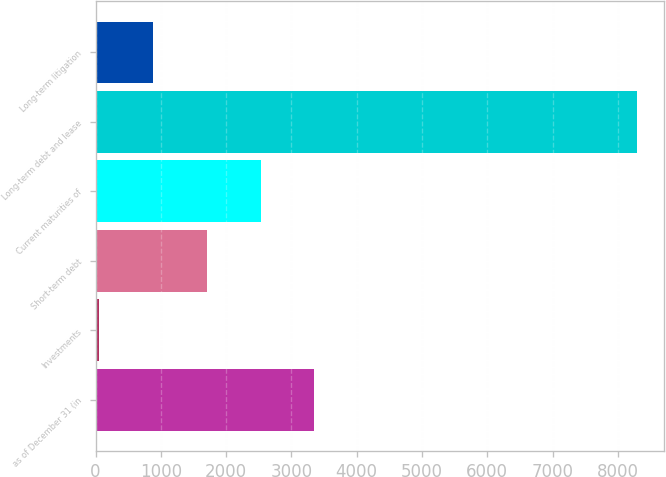Convert chart. <chart><loc_0><loc_0><loc_500><loc_500><bar_chart><fcel>as of December 31 (in<fcel>Investments<fcel>Short-term debt<fcel>Current maturities of<fcel>Long-term debt and lease<fcel>Long-term litigation<nl><fcel>3351<fcel>53<fcel>1702<fcel>2526.5<fcel>8298<fcel>877.5<nl></chart> 